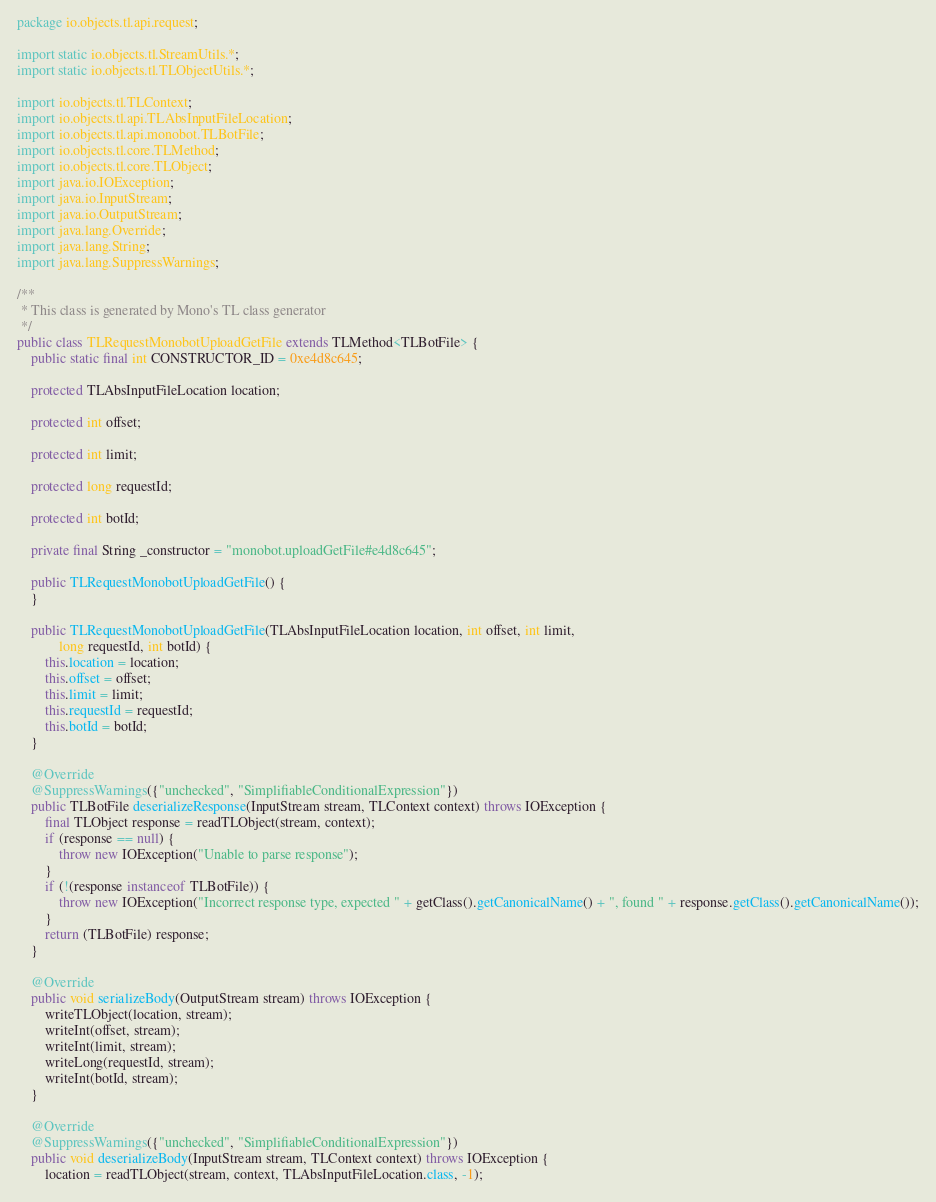Convert code to text. <code><loc_0><loc_0><loc_500><loc_500><_Java_>package io.objects.tl.api.request;

import static io.objects.tl.StreamUtils.*;
import static io.objects.tl.TLObjectUtils.*;

import io.objects.tl.TLContext;
import io.objects.tl.api.TLAbsInputFileLocation;
import io.objects.tl.api.monobot.TLBotFile;
import io.objects.tl.core.TLMethod;
import io.objects.tl.core.TLObject;
import java.io.IOException;
import java.io.InputStream;
import java.io.OutputStream;
import java.lang.Override;
import java.lang.String;
import java.lang.SuppressWarnings;

/**
 * This class is generated by Mono's TL class generator
 */
public class TLRequestMonobotUploadGetFile extends TLMethod<TLBotFile> {
    public static final int CONSTRUCTOR_ID = 0xe4d8c645;

    protected TLAbsInputFileLocation location;

    protected int offset;

    protected int limit;

    protected long requestId;

    protected int botId;

    private final String _constructor = "monobot.uploadGetFile#e4d8c645";

    public TLRequestMonobotUploadGetFile() {
    }

    public TLRequestMonobotUploadGetFile(TLAbsInputFileLocation location, int offset, int limit,
            long requestId, int botId) {
        this.location = location;
        this.offset = offset;
        this.limit = limit;
        this.requestId = requestId;
        this.botId = botId;
    }

    @Override
    @SuppressWarnings({"unchecked", "SimplifiableConditionalExpression"})
    public TLBotFile deserializeResponse(InputStream stream, TLContext context) throws IOException {
        final TLObject response = readTLObject(stream, context);
        if (response == null) {
            throw new IOException("Unable to parse response");
        }
        if (!(response instanceof TLBotFile)) {
            throw new IOException("Incorrect response type, expected " + getClass().getCanonicalName() + ", found " + response.getClass().getCanonicalName());
        }
        return (TLBotFile) response;
    }

    @Override
    public void serializeBody(OutputStream stream) throws IOException {
        writeTLObject(location, stream);
        writeInt(offset, stream);
        writeInt(limit, stream);
        writeLong(requestId, stream);
        writeInt(botId, stream);
    }

    @Override
    @SuppressWarnings({"unchecked", "SimplifiableConditionalExpression"})
    public void deserializeBody(InputStream stream, TLContext context) throws IOException {
        location = readTLObject(stream, context, TLAbsInputFileLocation.class, -1);</code> 